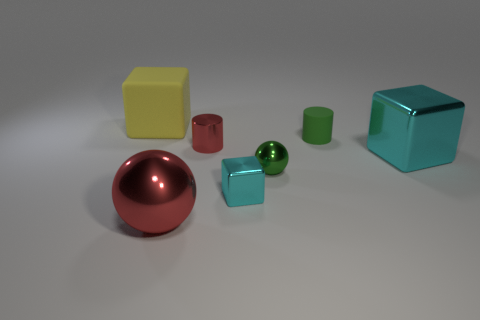Add 1 tiny yellow metallic cylinders. How many objects exist? 8 Subtract all cylinders. How many objects are left? 5 Subtract 0 yellow cylinders. How many objects are left? 7 Subtract all tiny yellow matte objects. Subtract all large red balls. How many objects are left? 6 Add 7 green things. How many green things are left? 9 Add 3 yellow matte blocks. How many yellow matte blocks exist? 4 